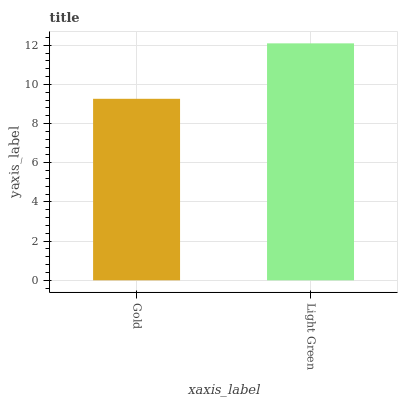Is Gold the minimum?
Answer yes or no. Yes. Is Light Green the maximum?
Answer yes or no. Yes. Is Light Green the minimum?
Answer yes or no. No. Is Light Green greater than Gold?
Answer yes or no. Yes. Is Gold less than Light Green?
Answer yes or no. Yes. Is Gold greater than Light Green?
Answer yes or no. No. Is Light Green less than Gold?
Answer yes or no. No. Is Light Green the high median?
Answer yes or no. Yes. Is Gold the low median?
Answer yes or no. Yes. Is Gold the high median?
Answer yes or no. No. Is Light Green the low median?
Answer yes or no. No. 